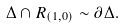<formula> <loc_0><loc_0><loc_500><loc_500>\Delta \cap R _ { ( 1 , 0 ) } \sim \partial \Delta .</formula> 